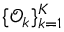<formula> <loc_0><loc_0><loc_500><loc_500>\{ \mathcal { O } _ { k } \} _ { k = 1 } ^ { K }</formula> 